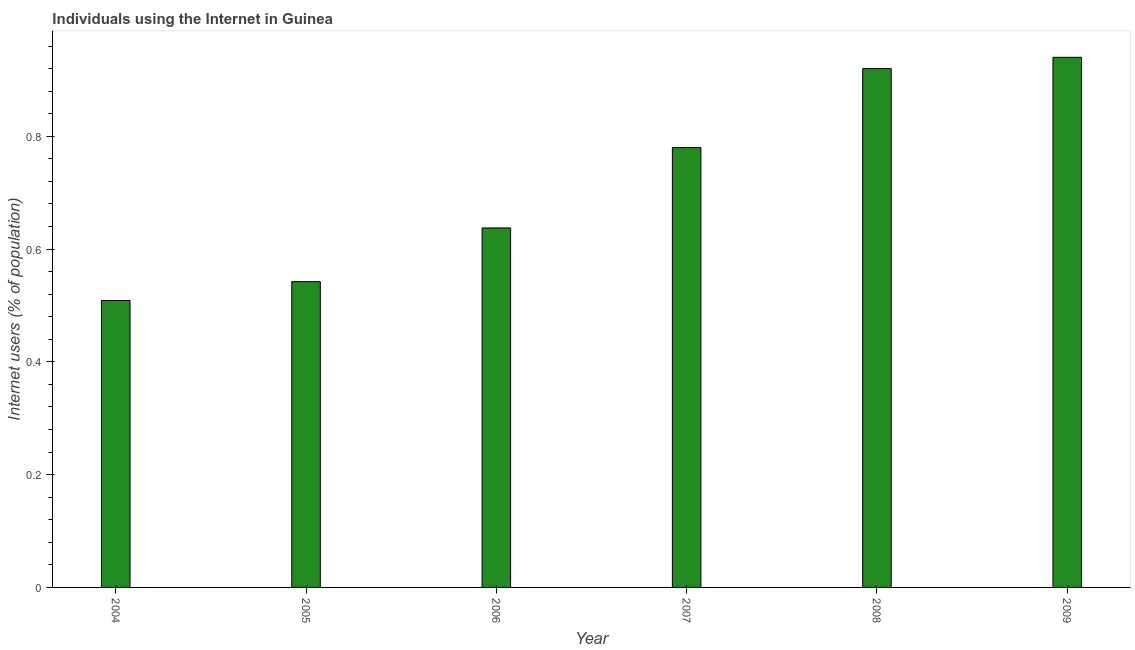Does the graph contain any zero values?
Provide a succinct answer. No. Does the graph contain grids?
Provide a short and direct response. No. What is the title of the graph?
Keep it short and to the point. Individuals using the Internet in Guinea. What is the label or title of the Y-axis?
Give a very brief answer. Internet users (% of population). Across all years, what is the minimum number of internet users?
Your response must be concise. 0.51. In which year was the number of internet users maximum?
Provide a succinct answer. 2009. What is the sum of the number of internet users?
Ensure brevity in your answer.  4.33. What is the difference between the number of internet users in 2004 and 2006?
Your response must be concise. -0.13. What is the average number of internet users per year?
Provide a short and direct response. 0.72. What is the median number of internet users?
Provide a succinct answer. 0.71. Do a majority of the years between 2006 and 2004 (inclusive) have number of internet users greater than 0.4 %?
Offer a terse response. Yes. What is the ratio of the number of internet users in 2008 to that in 2009?
Offer a terse response. 0.98. Is the sum of the number of internet users in 2004 and 2007 greater than the maximum number of internet users across all years?
Give a very brief answer. Yes. What is the difference between the highest and the lowest number of internet users?
Keep it short and to the point. 0.43. How many bars are there?
Offer a very short reply. 6. How many years are there in the graph?
Make the answer very short. 6. Are the values on the major ticks of Y-axis written in scientific E-notation?
Offer a terse response. No. What is the Internet users (% of population) of 2004?
Make the answer very short. 0.51. What is the Internet users (% of population) in 2005?
Ensure brevity in your answer.  0.54. What is the Internet users (% of population) of 2006?
Make the answer very short. 0.64. What is the Internet users (% of population) in 2007?
Your answer should be compact. 0.78. What is the Internet users (% of population) in 2009?
Provide a short and direct response. 0.94. What is the difference between the Internet users (% of population) in 2004 and 2005?
Your answer should be very brief. -0.03. What is the difference between the Internet users (% of population) in 2004 and 2006?
Offer a terse response. -0.13. What is the difference between the Internet users (% of population) in 2004 and 2007?
Offer a very short reply. -0.27. What is the difference between the Internet users (% of population) in 2004 and 2008?
Offer a terse response. -0.41. What is the difference between the Internet users (% of population) in 2004 and 2009?
Make the answer very short. -0.43. What is the difference between the Internet users (% of population) in 2005 and 2006?
Offer a very short reply. -0.1. What is the difference between the Internet users (% of population) in 2005 and 2007?
Offer a very short reply. -0.24. What is the difference between the Internet users (% of population) in 2005 and 2008?
Provide a short and direct response. -0.38. What is the difference between the Internet users (% of population) in 2005 and 2009?
Ensure brevity in your answer.  -0.4. What is the difference between the Internet users (% of population) in 2006 and 2007?
Your answer should be compact. -0.14. What is the difference between the Internet users (% of population) in 2006 and 2008?
Your answer should be very brief. -0.28. What is the difference between the Internet users (% of population) in 2006 and 2009?
Make the answer very short. -0.3. What is the difference between the Internet users (% of population) in 2007 and 2008?
Keep it short and to the point. -0.14. What is the difference between the Internet users (% of population) in 2007 and 2009?
Keep it short and to the point. -0.16. What is the difference between the Internet users (% of population) in 2008 and 2009?
Offer a very short reply. -0.02. What is the ratio of the Internet users (% of population) in 2004 to that in 2005?
Offer a very short reply. 0.94. What is the ratio of the Internet users (% of population) in 2004 to that in 2006?
Give a very brief answer. 0.8. What is the ratio of the Internet users (% of population) in 2004 to that in 2007?
Make the answer very short. 0.65. What is the ratio of the Internet users (% of population) in 2004 to that in 2008?
Your response must be concise. 0.55. What is the ratio of the Internet users (% of population) in 2004 to that in 2009?
Offer a very short reply. 0.54. What is the ratio of the Internet users (% of population) in 2005 to that in 2006?
Offer a terse response. 0.85. What is the ratio of the Internet users (% of population) in 2005 to that in 2007?
Provide a succinct answer. 0.69. What is the ratio of the Internet users (% of population) in 2005 to that in 2008?
Give a very brief answer. 0.59. What is the ratio of the Internet users (% of population) in 2005 to that in 2009?
Your answer should be very brief. 0.58. What is the ratio of the Internet users (% of population) in 2006 to that in 2007?
Your answer should be very brief. 0.82. What is the ratio of the Internet users (% of population) in 2006 to that in 2008?
Ensure brevity in your answer.  0.69. What is the ratio of the Internet users (% of population) in 2006 to that in 2009?
Your response must be concise. 0.68. What is the ratio of the Internet users (% of population) in 2007 to that in 2008?
Keep it short and to the point. 0.85. What is the ratio of the Internet users (% of population) in 2007 to that in 2009?
Your response must be concise. 0.83. What is the ratio of the Internet users (% of population) in 2008 to that in 2009?
Your answer should be very brief. 0.98. 